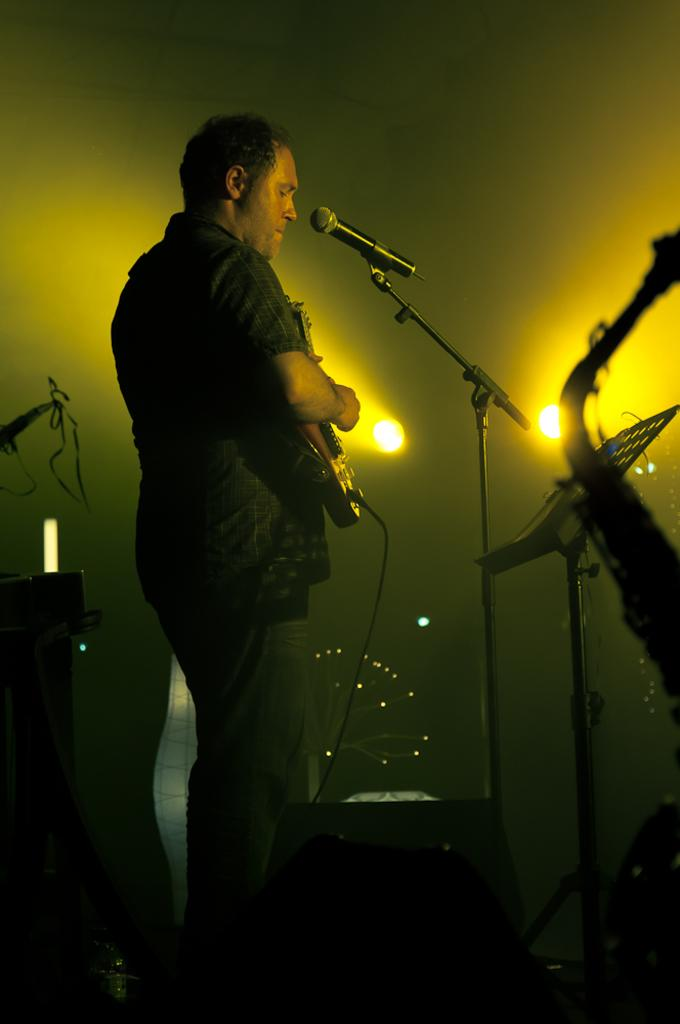Who is the main subject in the image? There is a man in the image. What is the man doing in the image? The man is standing in front of a microphone and playing a guitar. What can be seen in the background of the image? There is a wall and lights visible in the background of the image. What type of berry is the man holding in the image? There is no berry present in the image; the man is holding a guitar. What color are the man's lips in the image? The color of the man's lips cannot be determined from the image, as it does not provide enough detail about his facial features. 